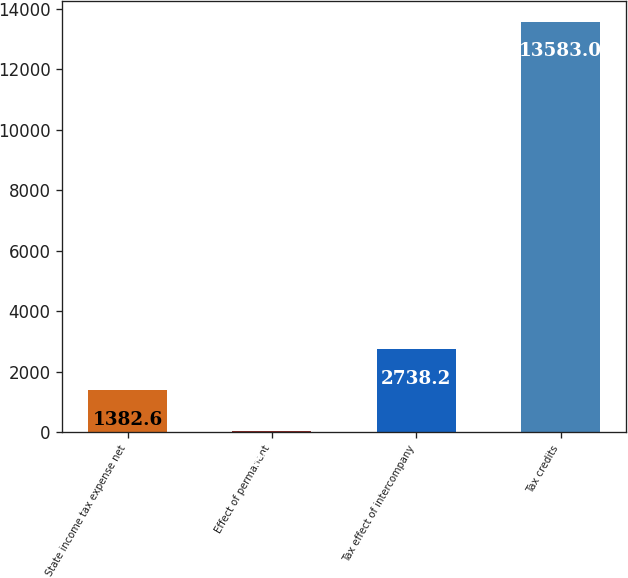Convert chart to OTSL. <chart><loc_0><loc_0><loc_500><loc_500><bar_chart><fcel>State income tax expense net<fcel>Effect of permanent<fcel>Tax effect of intercompany<fcel>Tax credits<nl><fcel>1382.6<fcel>27<fcel>2738.2<fcel>13583<nl></chart> 